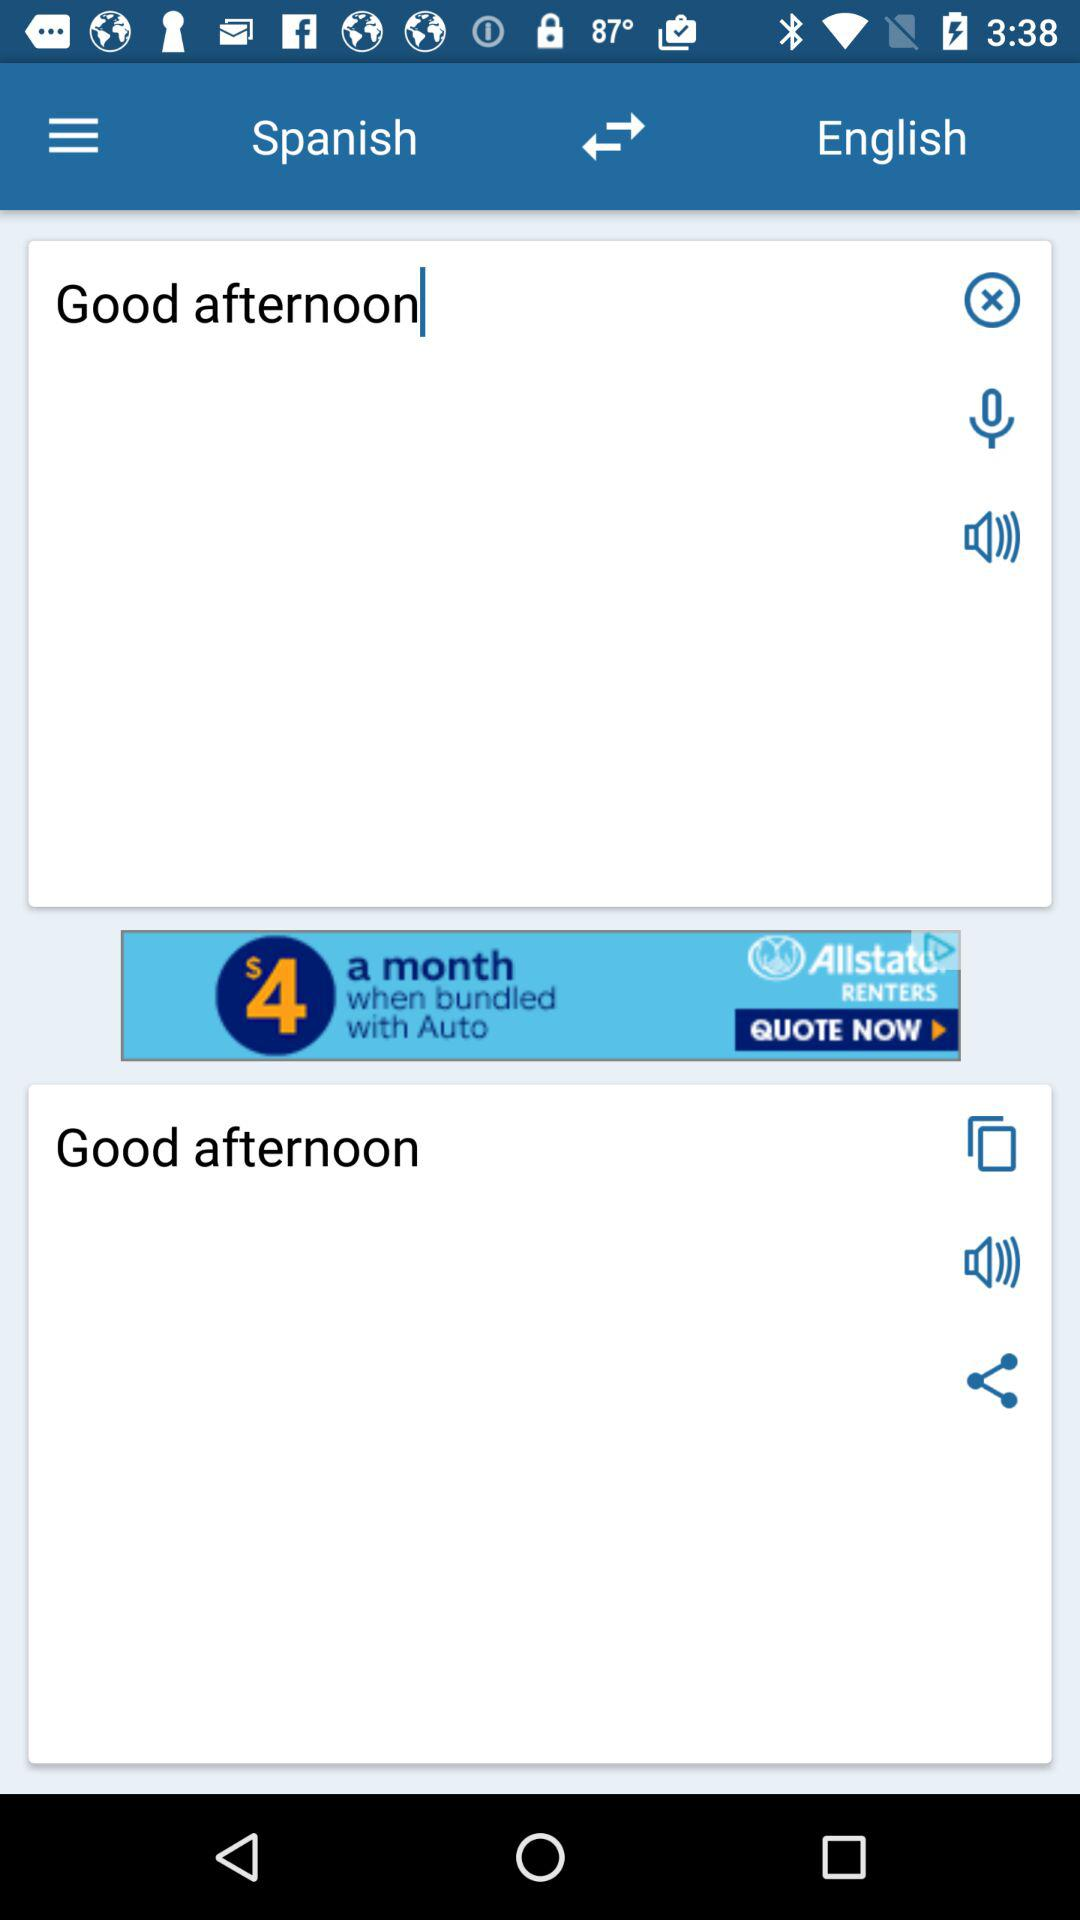What is the language translation paired with English? The paired language is Spanish. 